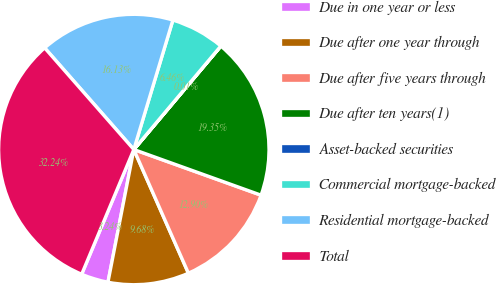Convert chart to OTSL. <chart><loc_0><loc_0><loc_500><loc_500><pie_chart><fcel>Due in one year or less<fcel>Due after one year through<fcel>Due after five years through<fcel>Due after ten years(1)<fcel>Asset-backed securities<fcel>Commercial mortgage-backed<fcel>Residential mortgage-backed<fcel>Total<nl><fcel>3.24%<fcel>9.68%<fcel>12.9%<fcel>19.35%<fcel>0.01%<fcel>6.46%<fcel>16.13%<fcel>32.24%<nl></chart> 